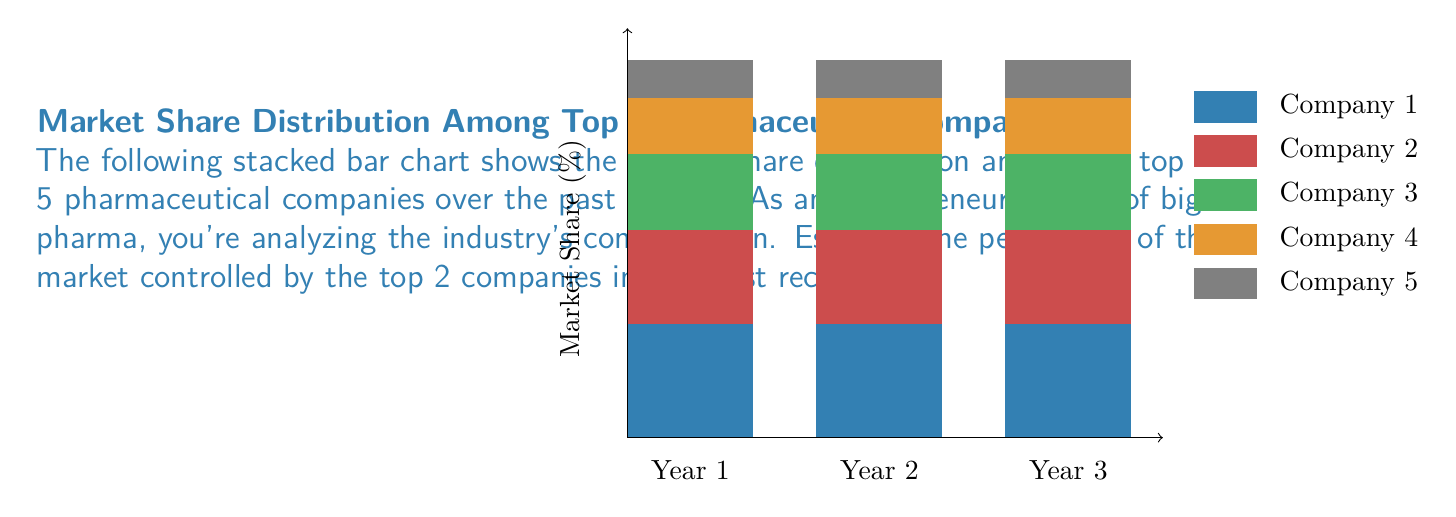Can you solve this math problem? To estimate the percentage of the market controlled by the top 2 companies in the most recent year (Year 3), we need to:

1. Identify the top 2 companies by market share in Year 3.
2. Estimate their individual market shares.
3. Sum these market shares.

From the stacked bar chart:

1. The top 2 companies are represented by the bottom two sections of each bar (blue and red).

2. Estimating their market shares in Year 3:
   - Company 1 (blue): Approximately 31% (1.9 units out of 6.1 total)
   - Company 2 (red): Approximately 25% (1.5 units out of 6.1 total)

3. Calculating the sum:
   $$ 31\% + 25\% = 56\% $$

Therefore, we estimate that the top 2 companies control approximately 56% of the market in the most recent year.

This high concentration of market share among just two companies illustrates the oligopolistic nature of the pharmaceutical industry, which is a common criticism from those skeptical of big pharma's practices.
Answer: 56% 